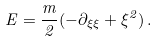Convert formula to latex. <formula><loc_0><loc_0><loc_500><loc_500>E = \frac { m } { 2 } ( - \partial _ { \xi \xi } + \xi ^ { 2 } ) \, .</formula> 